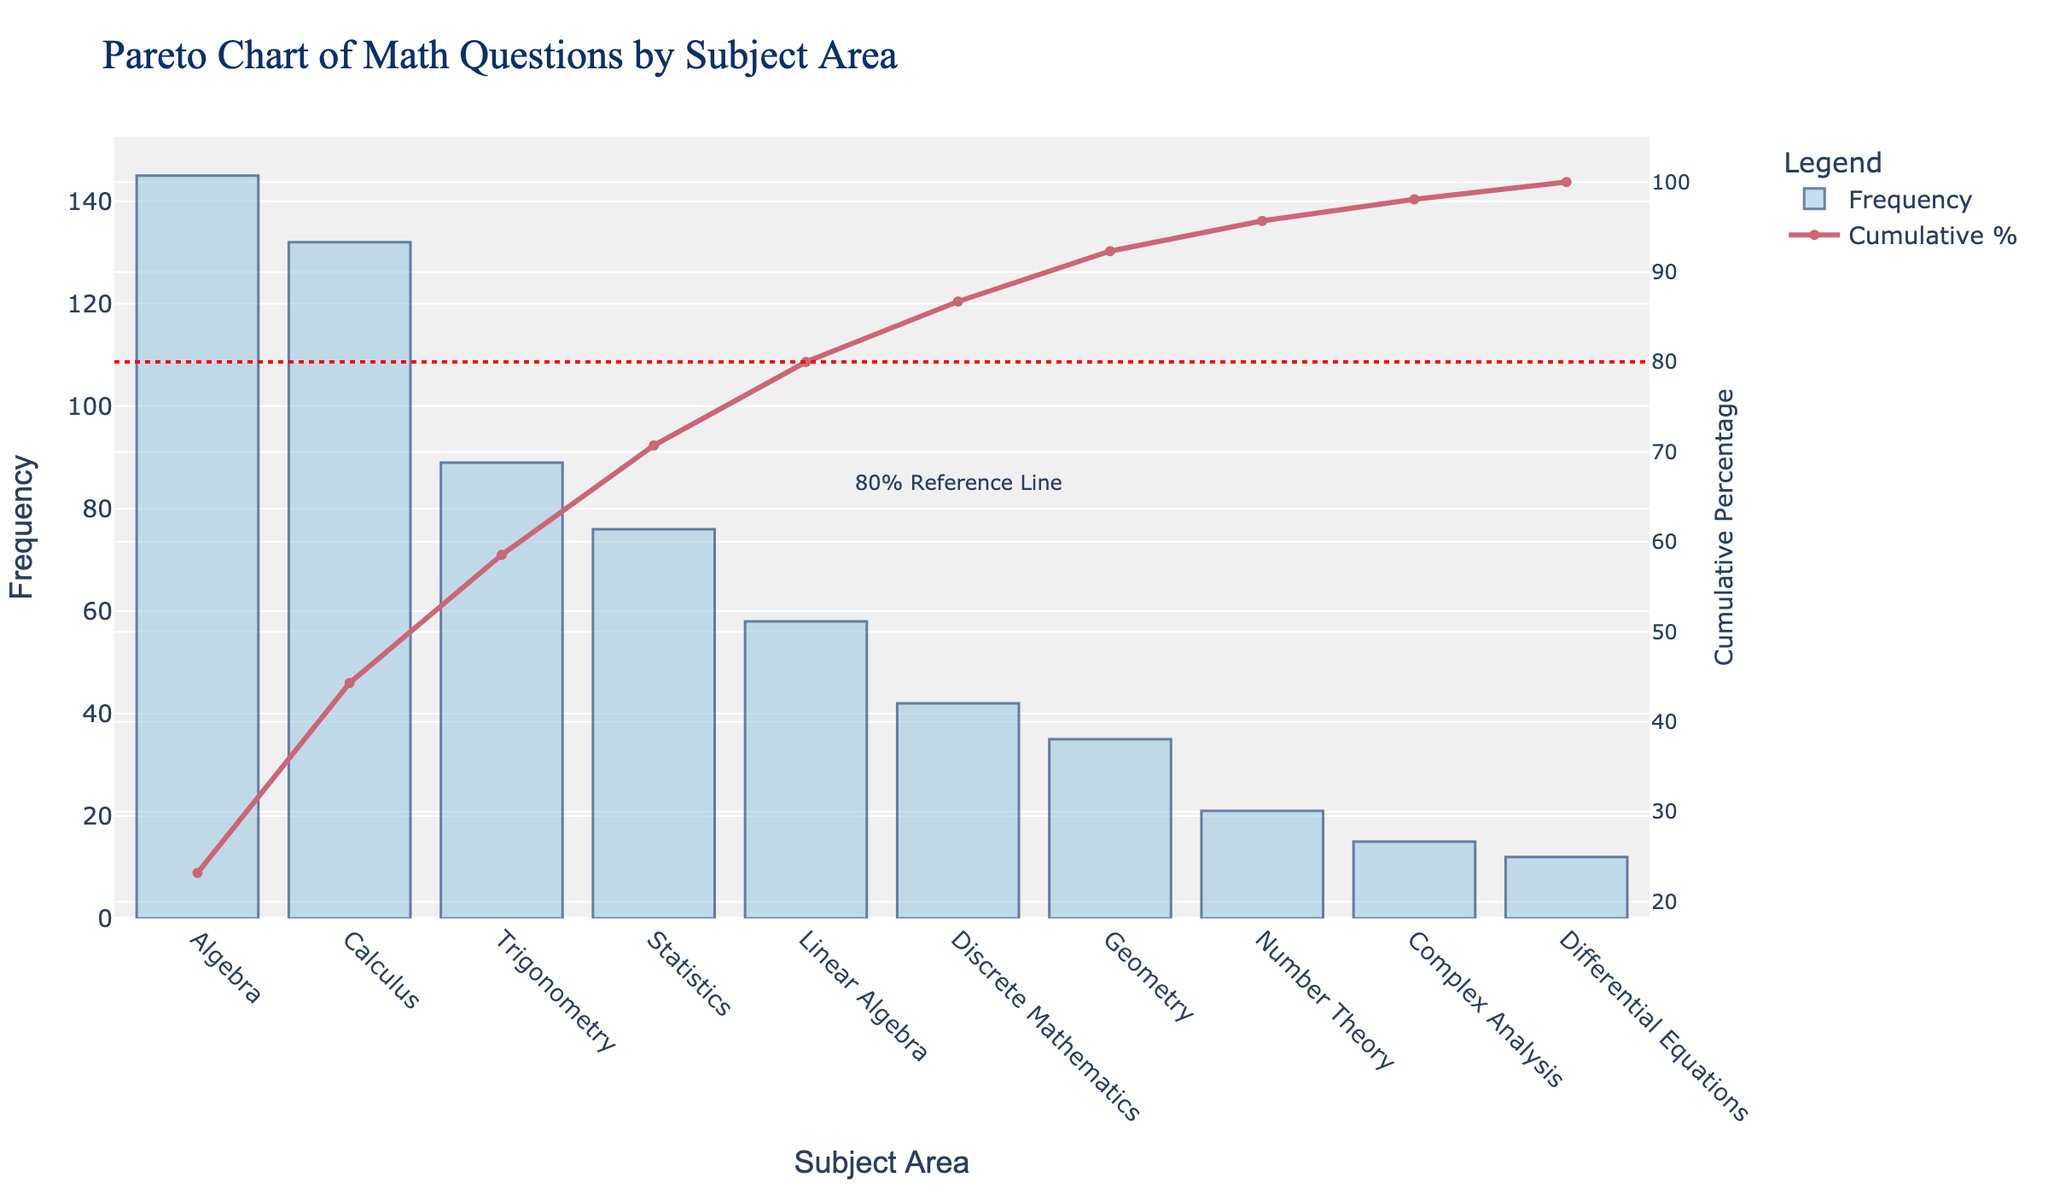What's the total frequency of Algebra questions? The y-axis indicates the frequency for Algebra is 145.
Answer: 145 What color represents the cumulative percentage line in the graph? The cumulative percentage line is represented by a reddish-pink color.
Answer: reddish-pink How many subject areas are listed in the figure? The x-axis lists 10 subject areas. Count each one to confirm the total.
Answer: 10 Which subject area has the lowest frequency of math questions? The bar at the rightmost of the x-axis represents Differential Equations with a frequency of 12, which is the lowest.
Answer: Differential Equations Are more questions asked about Algebra or Trigonometry? Compare the heights of the blue bars for Algebra and Trigonometry. The bar for Algebra is higher, indicating more questions are asked about Algebra.
Answer: Algebra What's the combined frequency of Calculus and Statistics questions? The frequency of Calculus is 132 and Statistics is 76. Add them together: 132 + 76 = 208.
Answer: 208 What subject area contributes to just passing the 80% cumulative percentage mark? The 80% reference line on the right y-axis is intersected slightly before Geometry. Count the cumulative areas: Algebra, Calculus, Trigonometry, then Statistics adds up to about 80%. Thus, Statistics contributes to passing the 80% mark.
Answer: Statistics Which subject has a frequency just above Linear Algebra? The bar next to Linear Algebra on the left represents Statistics with a frequency of 76, which is more than Linear Algebra's 58.
Answer: Statistics How much higher is the frequency of Algebra questions compared to Discrete Mathematics? Subtract the frequency of Discrete Mathematics (42) from Algebra (145): 145 - 42 = 103.
Answer: 103 What's the cumulative percentage after the fifth subject area? The y-axis on the right shows the cumulative percentage. At the Geometry point, the cumulative line is approximately 90%.
Answer: 90% 